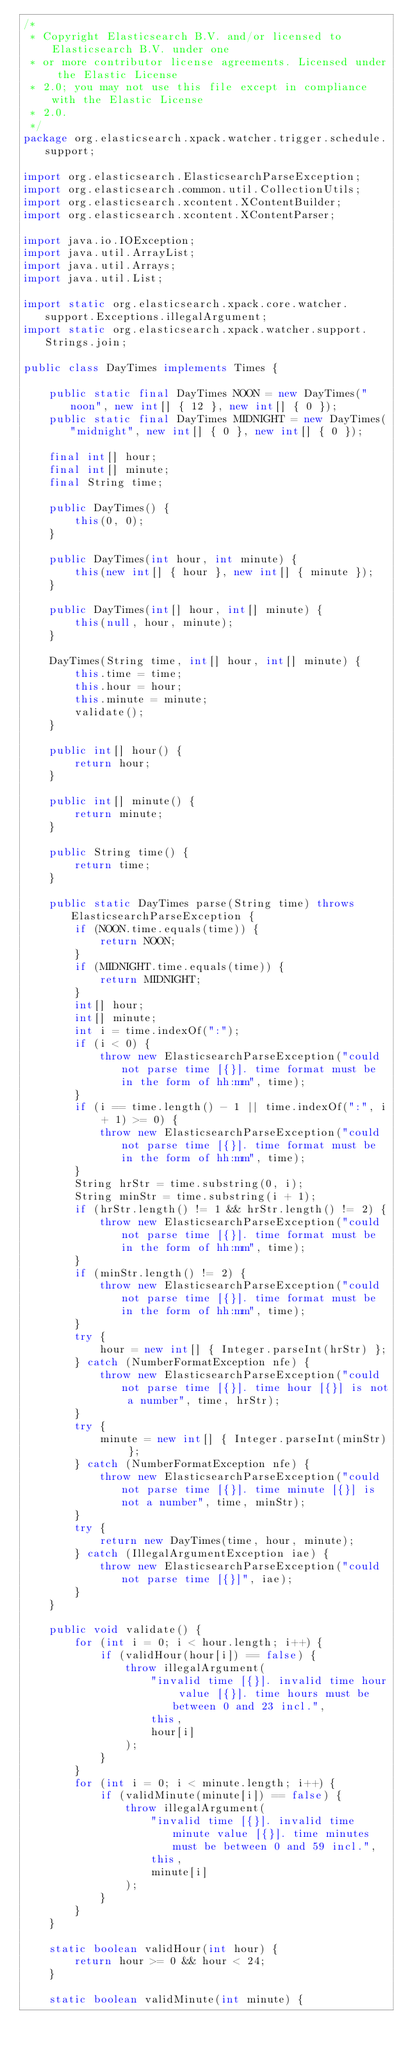Convert code to text. <code><loc_0><loc_0><loc_500><loc_500><_Java_>/*
 * Copyright Elasticsearch B.V. and/or licensed to Elasticsearch B.V. under one
 * or more contributor license agreements. Licensed under the Elastic License
 * 2.0; you may not use this file except in compliance with the Elastic License
 * 2.0.
 */
package org.elasticsearch.xpack.watcher.trigger.schedule.support;

import org.elasticsearch.ElasticsearchParseException;
import org.elasticsearch.common.util.CollectionUtils;
import org.elasticsearch.xcontent.XContentBuilder;
import org.elasticsearch.xcontent.XContentParser;

import java.io.IOException;
import java.util.ArrayList;
import java.util.Arrays;
import java.util.List;

import static org.elasticsearch.xpack.core.watcher.support.Exceptions.illegalArgument;
import static org.elasticsearch.xpack.watcher.support.Strings.join;

public class DayTimes implements Times {

    public static final DayTimes NOON = new DayTimes("noon", new int[] { 12 }, new int[] { 0 });
    public static final DayTimes MIDNIGHT = new DayTimes("midnight", new int[] { 0 }, new int[] { 0 });

    final int[] hour;
    final int[] minute;
    final String time;

    public DayTimes() {
        this(0, 0);
    }

    public DayTimes(int hour, int minute) {
        this(new int[] { hour }, new int[] { minute });
    }

    public DayTimes(int[] hour, int[] minute) {
        this(null, hour, minute);
    }

    DayTimes(String time, int[] hour, int[] minute) {
        this.time = time;
        this.hour = hour;
        this.minute = minute;
        validate();
    }

    public int[] hour() {
        return hour;
    }

    public int[] minute() {
        return minute;
    }

    public String time() {
        return time;
    }

    public static DayTimes parse(String time) throws ElasticsearchParseException {
        if (NOON.time.equals(time)) {
            return NOON;
        }
        if (MIDNIGHT.time.equals(time)) {
            return MIDNIGHT;
        }
        int[] hour;
        int[] minute;
        int i = time.indexOf(":");
        if (i < 0) {
            throw new ElasticsearchParseException("could not parse time [{}]. time format must be in the form of hh:mm", time);
        }
        if (i == time.length() - 1 || time.indexOf(":", i + 1) >= 0) {
            throw new ElasticsearchParseException("could not parse time [{}]. time format must be in the form of hh:mm", time);
        }
        String hrStr = time.substring(0, i);
        String minStr = time.substring(i + 1);
        if (hrStr.length() != 1 && hrStr.length() != 2) {
            throw new ElasticsearchParseException("could not parse time [{}]. time format must be in the form of hh:mm", time);
        }
        if (minStr.length() != 2) {
            throw new ElasticsearchParseException("could not parse time [{}]. time format must be in the form of hh:mm", time);
        }
        try {
            hour = new int[] { Integer.parseInt(hrStr) };
        } catch (NumberFormatException nfe) {
            throw new ElasticsearchParseException("could not parse time [{}]. time hour [{}] is not a number", time, hrStr);
        }
        try {
            minute = new int[] { Integer.parseInt(minStr) };
        } catch (NumberFormatException nfe) {
            throw new ElasticsearchParseException("could not parse time [{}]. time minute [{}] is not a number", time, minStr);
        }
        try {
            return new DayTimes(time, hour, minute);
        } catch (IllegalArgumentException iae) {
            throw new ElasticsearchParseException("could not parse time [{}]", iae);
        }
    }

    public void validate() {
        for (int i = 0; i < hour.length; i++) {
            if (validHour(hour[i]) == false) {
                throw illegalArgument(
                    "invalid time [{}]. invalid time hour value [{}]. time hours must be between 0 and 23 incl.",
                    this,
                    hour[i]
                );
            }
        }
        for (int i = 0; i < minute.length; i++) {
            if (validMinute(minute[i]) == false) {
                throw illegalArgument(
                    "invalid time [{}]. invalid time minute value [{}]. time minutes must be between 0 and 59 incl.",
                    this,
                    minute[i]
                );
            }
        }
    }

    static boolean validHour(int hour) {
        return hour >= 0 && hour < 24;
    }

    static boolean validMinute(int minute) {</code> 